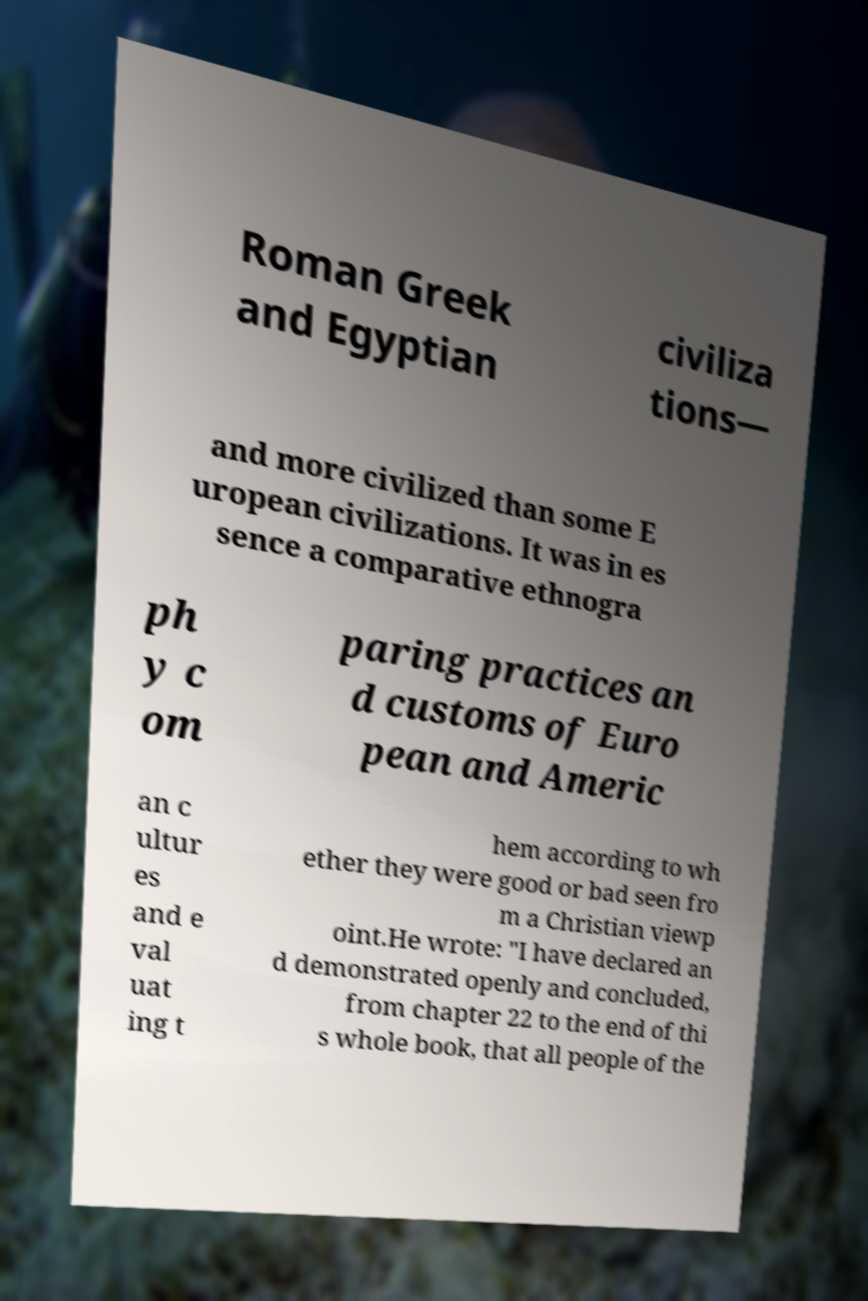Could you extract and type out the text from this image? Roman Greek and Egyptian civiliza tions— and more civilized than some E uropean civilizations. It was in es sence a comparative ethnogra ph y c om paring practices an d customs of Euro pean and Americ an c ultur es and e val uat ing t hem according to wh ether they were good or bad seen fro m a Christian viewp oint.He wrote: "I have declared an d demonstrated openly and concluded, from chapter 22 to the end of thi s whole book, that all people of the 